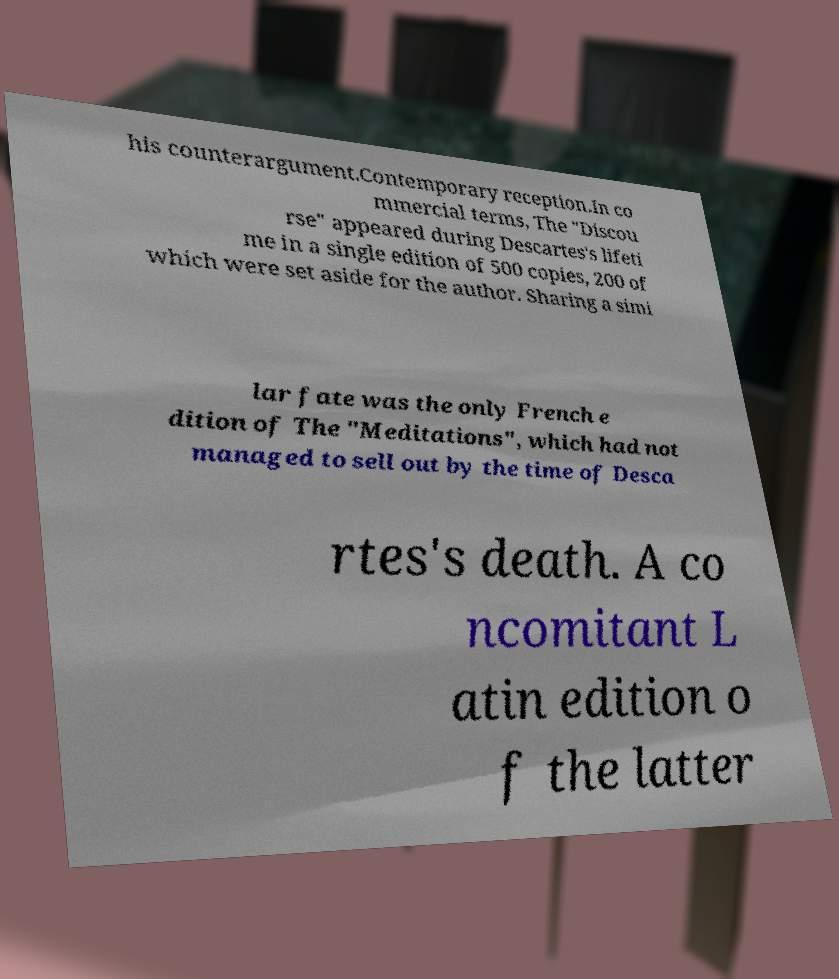For documentation purposes, I need the text within this image transcribed. Could you provide that? his counterargument.Contemporary reception.In co mmercial terms, The "Discou rse" appeared during Descartes's lifeti me in a single edition of 500 copies, 200 of which were set aside for the author. Sharing a simi lar fate was the only French e dition of The "Meditations", which had not managed to sell out by the time of Desca rtes's death. A co ncomitant L atin edition o f the latter 